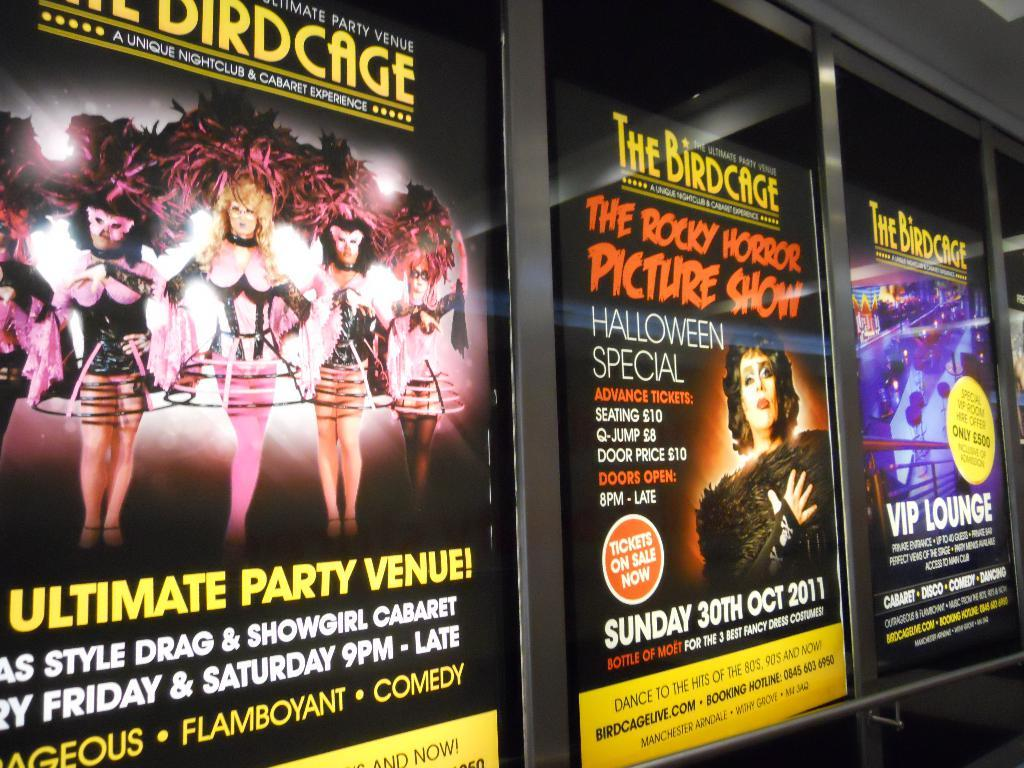<image>
Present a compact description of the photo's key features. a poster for The Rocky Horror Picture Show 